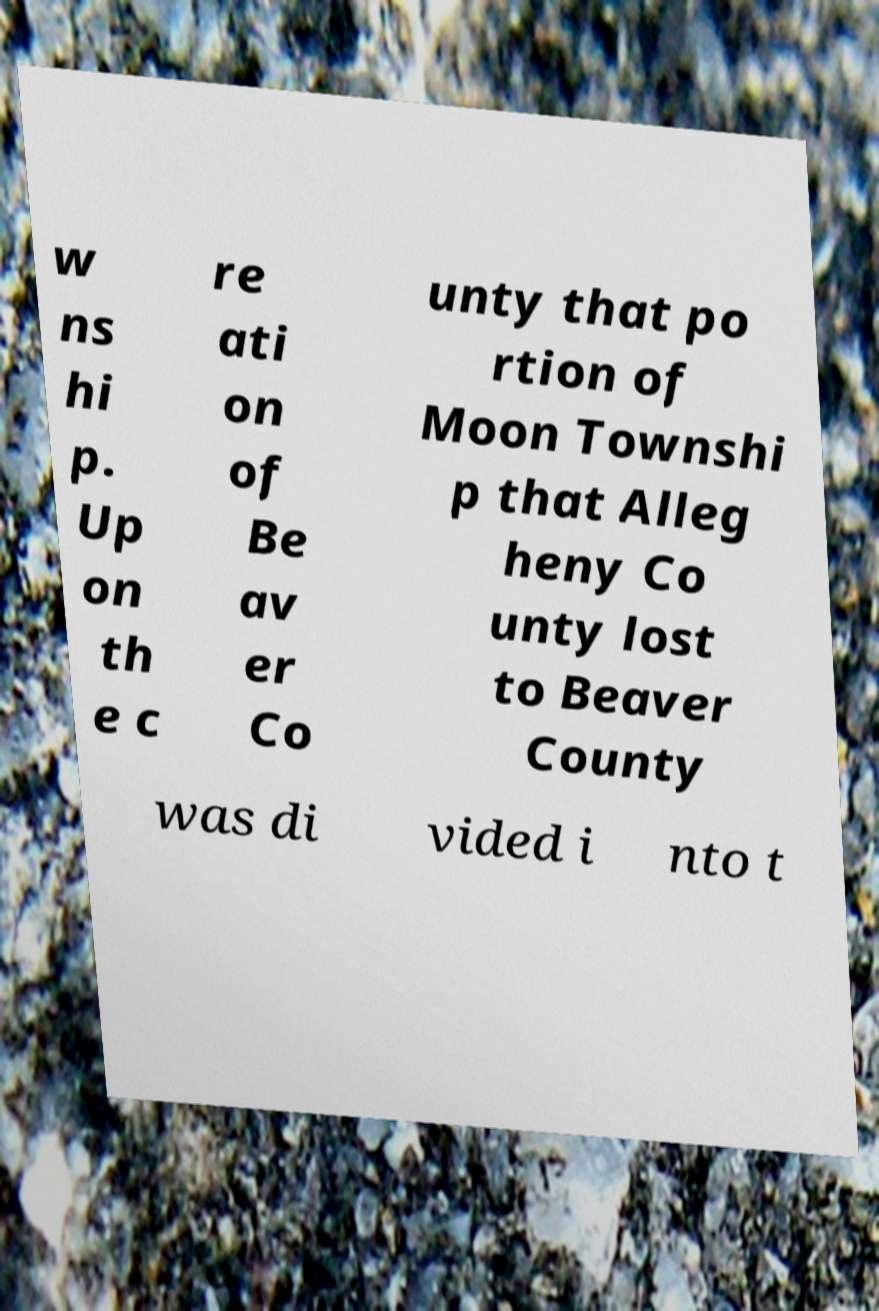Could you extract and type out the text from this image? w ns hi p. Up on th e c re ati on of Be av er Co unty that po rtion of Moon Townshi p that Alleg heny Co unty lost to Beaver County was di vided i nto t 